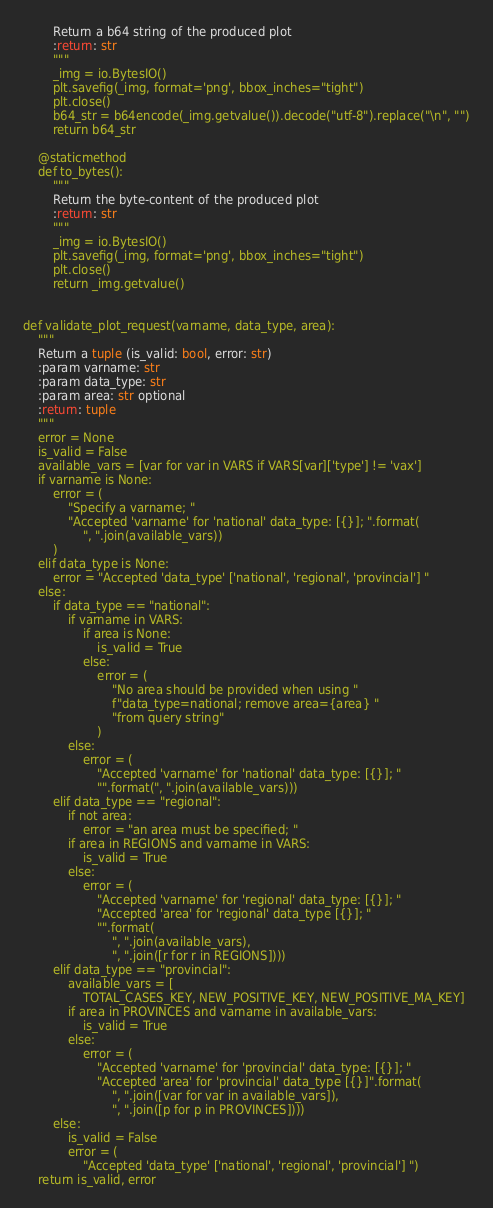<code> <loc_0><loc_0><loc_500><loc_500><_Python_>        Return a b64 string of the produced plot
        :return: str
        """
        _img = io.BytesIO()
        plt.savefig(_img, format='png', bbox_inches="tight")
        plt.close()
        b64_str = b64encode(_img.getvalue()).decode("utf-8").replace("\n", "")
        return b64_str

    @staticmethod
    def to_bytes():
        """
        Return the byte-content of the produced plot
        :return: str
        """
        _img = io.BytesIO()
        plt.savefig(_img, format='png', bbox_inches="tight")
        plt.close()
        return _img.getvalue()


def validate_plot_request(varname, data_type, area):
    """
    Return a tuple (is_valid: bool, error: str)
    :param varname: str
    :param data_type: str
    :param area: str optional
    :return: tuple
    """
    error = None
    is_valid = False
    available_vars = [var for var in VARS if VARS[var]['type'] != 'vax']
    if varname is None:
        error = (
            "Specify a varname; "
            "Accepted 'varname' for 'national' data_type: [{}]; ".format(
                ", ".join(available_vars))
        )
    elif data_type is None:
        error = "Accepted 'data_type' ['national', 'regional', 'provincial'] "
    else:
        if data_type == "national":
            if varname in VARS:
                if area is None:
                    is_valid = True
                else:
                    error = (
                        "No area should be provided when using "
                        f"data_type=national; remove area={area} "
                        "from query string"
                    )
            else:
                error = (
                    "Accepted 'varname' for 'national' data_type: [{}]; "
                    "".format(", ".join(available_vars)))
        elif data_type == "regional":
            if not area:
                error = "an area must be specified; "
            if area in REGIONS and varname in VARS:
                is_valid = True
            else:
                error = (
                    "Accepted 'varname' for 'regional' data_type: [{}]; "
                    "Accepted 'area' for 'regional' data_type [{}]; "
                    "".format(
                        ", ".join(available_vars),
                        ", ".join([r for r in REGIONS])))
        elif data_type == "provincial":
            available_vars = [
                TOTAL_CASES_KEY, NEW_POSITIVE_KEY, NEW_POSITIVE_MA_KEY]
            if area in PROVINCES and varname in available_vars:
                is_valid = True
            else:
                error = (
                    "Accepted 'varname' for 'provincial' data_type: [{}]; "
                    "Accepted 'area' for 'provincial' data_type [{}]".format(
                        ", ".join([var for var in available_vars]),
                        ", ".join([p for p in PROVINCES])))
        else:
            is_valid = False
            error = (
                "Accepted 'data_type' ['national', 'regional', 'provincial'] ")
    return is_valid, error
</code> 